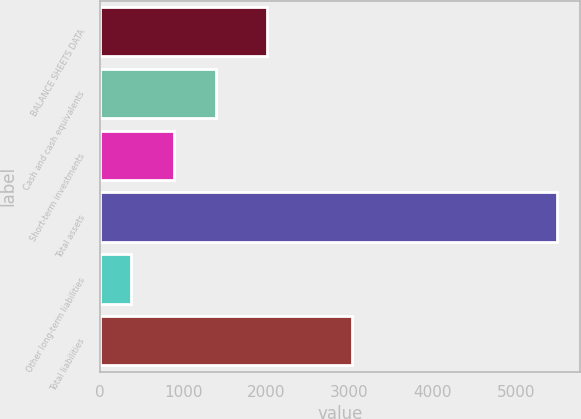Convert chart. <chart><loc_0><loc_0><loc_500><loc_500><bar_chart><fcel>BALANCE SHEETS DATA<fcel>Cash and cash equivalents<fcel>Short-term investments<fcel>Total assets<fcel>Other long-term liabilities<fcel>Total liabilities<nl><fcel>2012<fcel>1397.4<fcel>885.7<fcel>5491<fcel>374<fcel>3033<nl></chart> 